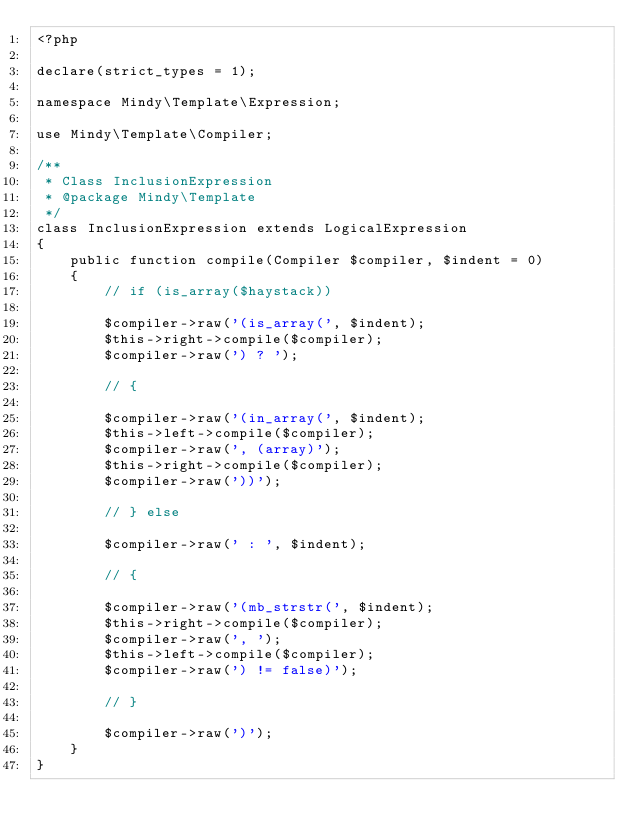Convert code to text. <code><loc_0><loc_0><loc_500><loc_500><_PHP_><?php

declare(strict_types = 1);

namespace Mindy\Template\Expression;

use Mindy\Template\Compiler;

/**
 * Class InclusionExpression
 * @package Mindy\Template
 */
class InclusionExpression extends LogicalExpression
{
    public function compile(Compiler $compiler, $indent = 0)
    {
        // if (is_array($haystack))

        $compiler->raw('(is_array(', $indent);
        $this->right->compile($compiler);
        $compiler->raw(') ? ');

        // {

        $compiler->raw('(in_array(', $indent);
        $this->left->compile($compiler);
        $compiler->raw(', (array)');
        $this->right->compile($compiler);
        $compiler->raw('))');

        // } else

        $compiler->raw(' : ', $indent);

        // {

        $compiler->raw('(mb_strstr(', $indent);
        $this->right->compile($compiler);
        $compiler->raw(', ');
        $this->left->compile($compiler);
        $compiler->raw(') != false)');

        // }

        $compiler->raw(')');
    }
}

</code> 